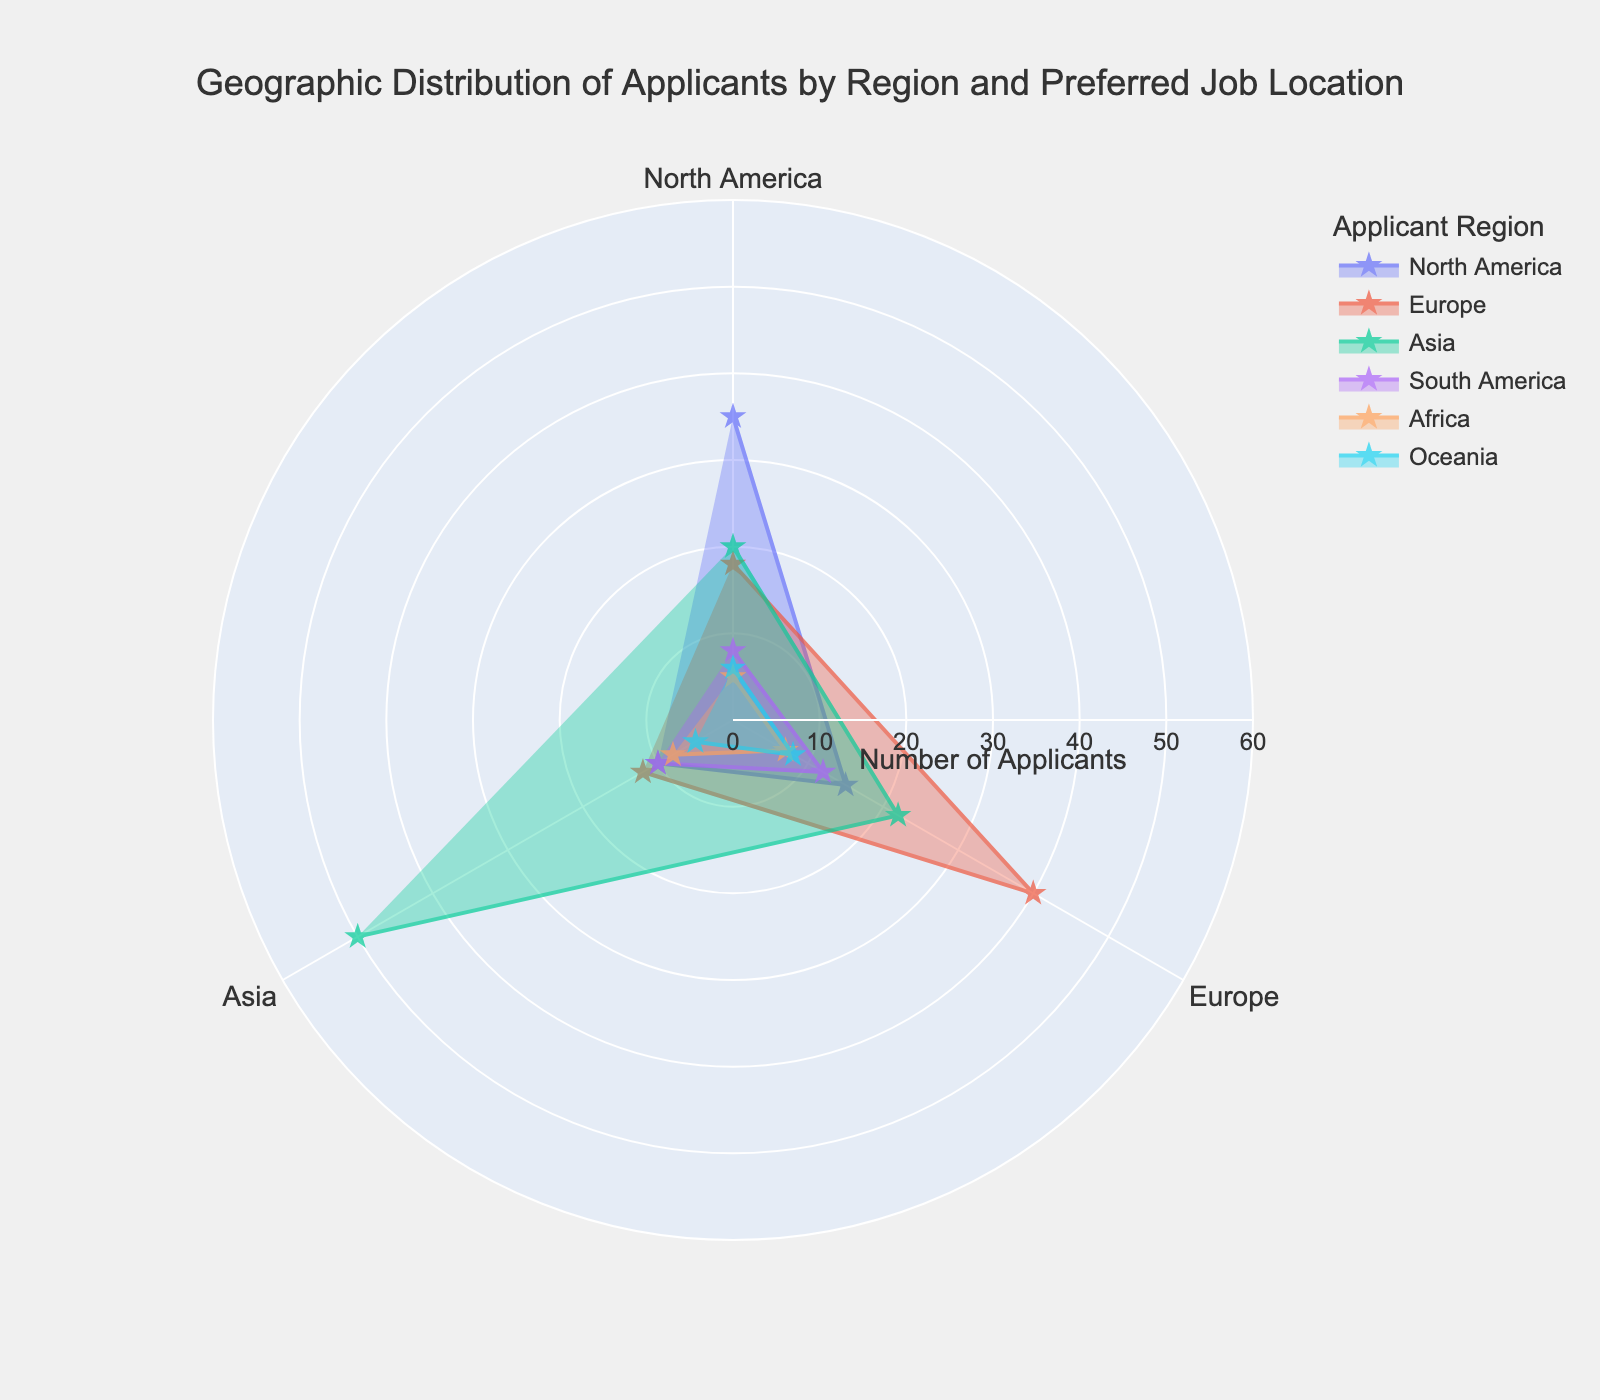What is the title of the figure? The title can be found at the top of the figure. It reads "Geographic Distribution of Applicants by Region and Preferred Job Location."
Answer: Geographic Distribution of Applicants by Region and Preferred Job Location Which two regions have the highest number of applicants preferring Europe as their job location? By examining the traces in the polar area chart, we can see that Europe and Asia show the highest data points for those preferring Europe with 40 and 22 applicants, respectively.
Answer: Europe, Asia How many applicants from Oceania prefer Asia as their job location? Looking at the Oceania trace in the chart, we can observe that the data point for Asia is marked at 5 applicants.
Answer: 5 Which region has the least number of applicants preferring North America? By comparing the radial distances for the regions towards North America, Africa shows the smallest data point with 5 applicants.
Answer: Africa What is the combined number of applicants from North America and Europe who prefer Asia? Adding the number of applicants from North America (10) and Europe (12) who prefer Asia, we get 10 + 12 = 22 applicants.
Answer: 22 Which job location is preferred the most by applicants from Asia, and how many applicants are there for this location? In the chart, the trace for Asia shows the highest radial distance towards Asia with 50 applicants.
Answer: Asia, 50 How many applicants from South America prefer North America and Europe combined? Adding the number of applicants from South America who prefer North America (8) and Europe (12), we get 8 + 12 = 20 applicants.
Answer: 20 Which region has the most diverse preference in job locations (i.e., non-zero values across all job locations)? By examining the chart, Europe shows non-zero values for all job locations (18 for North America, 40 for Europe, and 12 for Asia), indicating a diverse preference.
Answer: Europe Compare the total number of applicants from Africa and Oceania. Which has more applicants, and by how many? Summing up the number of applicants from Africa (5+7+8=20) and Oceania (6+8+5=19), we see Africa has 20 while Oceania has 19. Africa has 1 more applicant.
Answer: Africa, by 1 Which preferred job location has the highest overall number of applicants across all regions? By summing the values for each job location: North America (35+18+20+8+5+6=92), Europe (15+40+22+12+7+8=104), Asia (10+12+50+10+8+5=95), Europe has the highest overall number of applicants.
Answer: Europe 